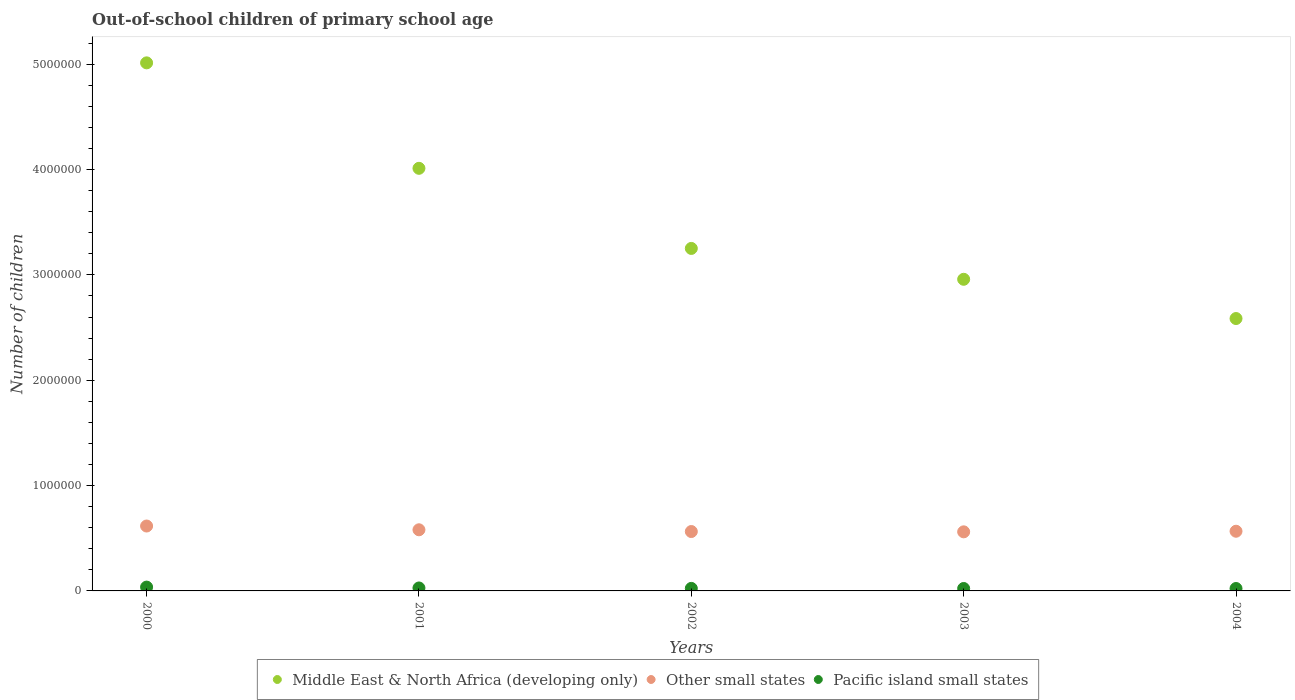How many different coloured dotlines are there?
Your answer should be very brief. 3. Is the number of dotlines equal to the number of legend labels?
Keep it short and to the point. Yes. What is the number of out-of-school children in Other small states in 2001?
Keep it short and to the point. 5.80e+05. Across all years, what is the maximum number of out-of-school children in Middle East & North Africa (developing only)?
Ensure brevity in your answer.  5.01e+06. Across all years, what is the minimum number of out-of-school children in Pacific island small states?
Make the answer very short. 2.30e+04. What is the total number of out-of-school children in Other small states in the graph?
Offer a terse response. 2.89e+06. What is the difference between the number of out-of-school children in Middle East & North Africa (developing only) in 2001 and that in 2004?
Your answer should be very brief. 1.43e+06. What is the difference between the number of out-of-school children in Other small states in 2004 and the number of out-of-school children in Pacific island small states in 2000?
Ensure brevity in your answer.  5.30e+05. What is the average number of out-of-school children in Other small states per year?
Keep it short and to the point. 5.78e+05. In the year 2004, what is the difference between the number of out-of-school children in Middle East & North Africa (developing only) and number of out-of-school children in Other small states?
Your answer should be very brief. 2.02e+06. What is the ratio of the number of out-of-school children in Other small states in 2002 to that in 2003?
Your answer should be very brief. 1.01. Is the number of out-of-school children in Pacific island small states in 2000 less than that in 2001?
Your answer should be compact. No. What is the difference between the highest and the second highest number of out-of-school children in Other small states?
Ensure brevity in your answer.  3.57e+04. What is the difference between the highest and the lowest number of out-of-school children in Pacific island small states?
Make the answer very short. 1.33e+04. Is it the case that in every year, the sum of the number of out-of-school children in Middle East & North Africa (developing only) and number of out-of-school children in Other small states  is greater than the number of out-of-school children in Pacific island small states?
Your answer should be compact. Yes. Is the number of out-of-school children in Pacific island small states strictly greater than the number of out-of-school children in Middle East & North Africa (developing only) over the years?
Provide a short and direct response. No. Is the number of out-of-school children in Middle East & North Africa (developing only) strictly less than the number of out-of-school children in Other small states over the years?
Your response must be concise. No. Are the values on the major ticks of Y-axis written in scientific E-notation?
Ensure brevity in your answer.  No. Does the graph contain grids?
Your response must be concise. No. How many legend labels are there?
Make the answer very short. 3. What is the title of the graph?
Make the answer very short. Out-of-school children of primary school age. What is the label or title of the Y-axis?
Keep it short and to the point. Number of children. What is the Number of children of Middle East & North Africa (developing only) in 2000?
Ensure brevity in your answer.  5.01e+06. What is the Number of children in Other small states in 2000?
Provide a short and direct response. 6.16e+05. What is the Number of children in Pacific island small states in 2000?
Your answer should be very brief. 3.63e+04. What is the Number of children of Middle East & North Africa (developing only) in 2001?
Your answer should be compact. 4.01e+06. What is the Number of children of Other small states in 2001?
Provide a short and direct response. 5.80e+05. What is the Number of children of Pacific island small states in 2001?
Keep it short and to the point. 2.80e+04. What is the Number of children in Middle East & North Africa (developing only) in 2002?
Your response must be concise. 3.25e+06. What is the Number of children of Other small states in 2002?
Your response must be concise. 5.64e+05. What is the Number of children of Pacific island small states in 2002?
Make the answer very short. 2.40e+04. What is the Number of children of Middle East & North Africa (developing only) in 2003?
Your response must be concise. 2.96e+06. What is the Number of children in Other small states in 2003?
Your response must be concise. 5.61e+05. What is the Number of children of Pacific island small states in 2003?
Keep it short and to the point. 2.30e+04. What is the Number of children in Middle East & North Africa (developing only) in 2004?
Keep it short and to the point. 2.59e+06. What is the Number of children in Other small states in 2004?
Provide a succinct answer. 5.67e+05. What is the Number of children of Pacific island small states in 2004?
Keep it short and to the point. 2.30e+04. Across all years, what is the maximum Number of children in Middle East & North Africa (developing only)?
Provide a succinct answer. 5.01e+06. Across all years, what is the maximum Number of children in Other small states?
Ensure brevity in your answer.  6.16e+05. Across all years, what is the maximum Number of children in Pacific island small states?
Provide a succinct answer. 3.63e+04. Across all years, what is the minimum Number of children of Middle East & North Africa (developing only)?
Keep it short and to the point. 2.59e+06. Across all years, what is the minimum Number of children of Other small states?
Offer a very short reply. 5.61e+05. Across all years, what is the minimum Number of children of Pacific island small states?
Offer a terse response. 2.30e+04. What is the total Number of children in Middle East & North Africa (developing only) in the graph?
Keep it short and to the point. 1.78e+07. What is the total Number of children in Other small states in the graph?
Offer a very short reply. 2.89e+06. What is the total Number of children of Pacific island small states in the graph?
Offer a terse response. 1.34e+05. What is the difference between the Number of children in Middle East & North Africa (developing only) in 2000 and that in 2001?
Offer a terse response. 1.00e+06. What is the difference between the Number of children in Other small states in 2000 and that in 2001?
Provide a short and direct response. 3.57e+04. What is the difference between the Number of children of Pacific island small states in 2000 and that in 2001?
Your answer should be compact. 8231. What is the difference between the Number of children in Middle East & North Africa (developing only) in 2000 and that in 2002?
Your answer should be very brief. 1.76e+06. What is the difference between the Number of children in Other small states in 2000 and that in 2002?
Your answer should be very brief. 5.24e+04. What is the difference between the Number of children of Pacific island small states in 2000 and that in 2002?
Your answer should be compact. 1.23e+04. What is the difference between the Number of children in Middle East & North Africa (developing only) in 2000 and that in 2003?
Your answer should be compact. 2.05e+06. What is the difference between the Number of children of Other small states in 2000 and that in 2003?
Provide a succinct answer. 5.52e+04. What is the difference between the Number of children of Pacific island small states in 2000 and that in 2003?
Keep it short and to the point. 1.33e+04. What is the difference between the Number of children in Middle East & North Africa (developing only) in 2000 and that in 2004?
Ensure brevity in your answer.  2.43e+06. What is the difference between the Number of children in Other small states in 2000 and that in 2004?
Your answer should be very brief. 4.96e+04. What is the difference between the Number of children in Pacific island small states in 2000 and that in 2004?
Your answer should be very brief. 1.33e+04. What is the difference between the Number of children in Middle East & North Africa (developing only) in 2001 and that in 2002?
Offer a very short reply. 7.60e+05. What is the difference between the Number of children in Other small states in 2001 and that in 2002?
Your response must be concise. 1.66e+04. What is the difference between the Number of children in Pacific island small states in 2001 and that in 2002?
Give a very brief answer. 4058. What is the difference between the Number of children in Middle East & North Africa (developing only) in 2001 and that in 2003?
Your answer should be compact. 1.05e+06. What is the difference between the Number of children of Other small states in 2001 and that in 2003?
Offer a very short reply. 1.95e+04. What is the difference between the Number of children in Pacific island small states in 2001 and that in 2003?
Your answer should be compact. 5020. What is the difference between the Number of children of Middle East & North Africa (developing only) in 2001 and that in 2004?
Ensure brevity in your answer.  1.43e+06. What is the difference between the Number of children of Other small states in 2001 and that in 2004?
Give a very brief answer. 1.38e+04. What is the difference between the Number of children of Pacific island small states in 2001 and that in 2004?
Your answer should be compact. 5055. What is the difference between the Number of children in Middle East & North Africa (developing only) in 2002 and that in 2003?
Give a very brief answer. 2.93e+05. What is the difference between the Number of children in Other small states in 2002 and that in 2003?
Ensure brevity in your answer.  2824. What is the difference between the Number of children of Pacific island small states in 2002 and that in 2003?
Give a very brief answer. 962. What is the difference between the Number of children in Middle East & North Africa (developing only) in 2002 and that in 2004?
Your response must be concise. 6.65e+05. What is the difference between the Number of children of Other small states in 2002 and that in 2004?
Make the answer very short. -2803. What is the difference between the Number of children of Pacific island small states in 2002 and that in 2004?
Your answer should be compact. 997. What is the difference between the Number of children of Middle East & North Africa (developing only) in 2003 and that in 2004?
Offer a terse response. 3.73e+05. What is the difference between the Number of children of Other small states in 2003 and that in 2004?
Your response must be concise. -5627. What is the difference between the Number of children of Pacific island small states in 2003 and that in 2004?
Your answer should be compact. 35. What is the difference between the Number of children in Middle East & North Africa (developing only) in 2000 and the Number of children in Other small states in 2001?
Provide a short and direct response. 4.43e+06. What is the difference between the Number of children in Middle East & North Africa (developing only) in 2000 and the Number of children in Pacific island small states in 2001?
Ensure brevity in your answer.  4.98e+06. What is the difference between the Number of children of Other small states in 2000 and the Number of children of Pacific island small states in 2001?
Your answer should be very brief. 5.88e+05. What is the difference between the Number of children in Middle East & North Africa (developing only) in 2000 and the Number of children in Other small states in 2002?
Keep it short and to the point. 4.45e+06. What is the difference between the Number of children in Middle East & North Africa (developing only) in 2000 and the Number of children in Pacific island small states in 2002?
Keep it short and to the point. 4.99e+06. What is the difference between the Number of children in Other small states in 2000 and the Number of children in Pacific island small states in 2002?
Give a very brief answer. 5.92e+05. What is the difference between the Number of children of Middle East & North Africa (developing only) in 2000 and the Number of children of Other small states in 2003?
Give a very brief answer. 4.45e+06. What is the difference between the Number of children of Middle East & North Africa (developing only) in 2000 and the Number of children of Pacific island small states in 2003?
Keep it short and to the point. 4.99e+06. What is the difference between the Number of children in Other small states in 2000 and the Number of children in Pacific island small states in 2003?
Ensure brevity in your answer.  5.93e+05. What is the difference between the Number of children in Middle East & North Africa (developing only) in 2000 and the Number of children in Other small states in 2004?
Provide a succinct answer. 4.45e+06. What is the difference between the Number of children of Middle East & North Africa (developing only) in 2000 and the Number of children of Pacific island small states in 2004?
Offer a terse response. 4.99e+06. What is the difference between the Number of children in Other small states in 2000 and the Number of children in Pacific island small states in 2004?
Your response must be concise. 5.93e+05. What is the difference between the Number of children of Middle East & North Africa (developing only) in 2001 and the Number of children of Other small states in 2002?
Your response must be concise. 3.45e+06. What is the difference between the Number of children of Middle East & North Africa (developing only) in 2001 and the Number of children of Pacific island small states in 2002?
Your answer should be very brief. 3.99e+06. What is the difference between the Number of children in Other small states in 2001 and the Number of children in Pacific island small states in 2002?
Give a very brief answer. 5.56e+05. What is the difference between the Number of children of Middle East & North Africa (developing only) in 2001 and the Number of children of Other small states in 2003?
Offer a very short reply. 3.45e+06. What is the difference between the Number of children of Middle East & North Africa (developing only) in 2001 and the Number of children of Pacific island small states in 2003?
Provide a short and direct response. 3.99e+06. What is the difference between the Number of children in Other small states in 2001 and the Number of children in Pacific island small states in 2003?
Keep it short and to the point. 5.57e+05. What is the difference between the Number of children of Middle East & North Africa (developing only) in 2001 and the Number of children of Other small states in 2004?
Provide a succinct answer. 3.45e+06. What is the difference between the Number of children of Middle East & North Africa (developing only) in 2001 and the Number of children of Pacific island small states in 2004?
Your response must be concise. 3.99e+06. What is the difference between the Number of children in Other small states in 2001 and the Number of children in Pacific island small states in 2004?
Offer a terse response. 5.57e+05. What is the difference between the Number of children in Middle East & North Africa (developing only) in 2002 and the Number of children in Other small states in 2003?
Your answer should be compact. 2.69e+06. What is the difference between the Number of children of Middle East & North Africa (developing only) in 2002 and the Number of children of Pacific island small states in 2003?
Your answer should be compact. 3.23e+06. What is the difference between the Number of children of Other small states in 2002 and the Number of children of Pacific island small states in 2003?
Your response must be concise. 5.41e+05. What is the difference between the Number of children in Middle East & North Africa (developing only) in 2002 and the Number of children in Other small states in 2004?
Ensure brevity in your answer.  2.68e+06. What is the difference between the Number of children of Middle East & North Africa (developing only) in 2002 and the Number of children of Pacific island small states in 2004?
Provide a succinct answer. 3.23e+06. What is the difference between the Number of children in Other small states in 2002 and the Number of children in Pacific island small states in 2004?
Ensure brevity in your answer.  5.41e+05. What is the difference between the Number of children in Middle East & North Africa (developing only) in 2003 and the Number of children in Other small states in 2004?
Make the answer very short. 2.39e+06. What is the difference between the Number of children in Middle East & North Africa (developing only) in 2003 and the Number of children in Pacific island small states in 2004?
Provide a succinct answer. 2.94e+06. What is the difference between the Number of children in Other small states in 2003 and the Number of children in Pacific island small states in 2004?
Keep it short and to the point. 5.38e+05. What is the average Number of children of Middle East & North Africa (developing only) per year?
Provide a short and direct response. 3.56e+06. What is the average Number of children in Other small states per year?
Give a very brief answer. 5.78e+05. What is the average Number of children of Pacific island small states per year?
Your response must be concise. 2.69e+04. In the year 2000, what is the difference between the Number of children of Middle East & North Africa (developing only) and Number of children of Other small states?
Ensure brevity in your answer.  4.40e+06. In the year 2000, what is the difference between the Number of children of Middle East & North Africa (developing only) and Number of children of Pacific island small states?
Your answer should be compact. 4.98e+06. In the year 2000, what is the difference between the Number of children of Other small states and Number of children of Pacific island small states?
Offer a terse response. 5.80e+05. In the year 2001, what is the difference between the Number of children in Middle East & North Africa (developing only) and Number of children in Other small states?
Your answer should be compact. 3.43e+06. In the year 2001, what is the difference between the Number of children of Middle East & North Africa (developing only) and Number of children of Pacific island small states?
Your response must be concise. 3.98e+06. In the year 2001, what is the difference between the Number of children in Other small states and Number of children in Pacific island small states?
Your answer should be compact. 5.52e+05. In the year 2002, what is the difference between the Number of children of Middle East & North Africa (developing only) and Number of children of Other small states?
Give a very brief answer. 2.69e+06. In the year 2002, what is the difference between the Number of children of Middle East & North Africa (developing only) and Number of children of Pacific island small states?
Offer a terse response. 3.23e+06. In the year 2002, what is the difference between the Number of children of Other small states and Number of children of Pacific island small states?
Make the answer very short. 5.40e+05. In the year 2003, what is the difference between the Number of children in Middle East & North Africa (developing only) and Number of children in Other small states?
Provide a succinct answer. 2.40e+06. In the year 2003, what is the difference between the Number of children of Middle East & North Africa (developing only) and Number of children of Pacific island small states?
Your answer should be compact. 2.94e+06. In the year 2003, what is the difference between the Number of children in Other small states and Number of children in Pacific island small states?
Your answer should be very brief. 5.38e+05. In the year 2004, what is the difference between the Number of children of Middle East & North Africa (developing only) and Number of children of Other small states?
Make the answer very short. 2.02e+06. In the year 2004, what is the difference between the Number of children of Middle East & North Africa (developing only) and Number of children of Pacific island small states?
Give a very brief answer. 2.56e+06. In the year 2004, what is the difference between the Number of children of Other small states and Number of children of Pacific island small states?
Your response must be concise. 5.44e+05. What is the ratio of the Number of children of Middle East & North Africa (developing only) in 2000 to that in 2001?
Offer a very short reply. 1.25. What is the ratio of the Number of children in Other small states in 2000 to that in 2001?
Give a very brief answer. 1.06. What is the ratio of the Number of children of Pacific island small states in 2000 to that in 2001?
Make the answer very short. 1.29. What is the ratio of the Number of children in Middle East & North Africa (developing only) in 2000 to that in 2002?
Ensure brevity in your answer.  1.54. What is the ratio of the Number of children of Other small states in 2000 to that in 2002?
Make the answer very short. 1.09. What is the ratio of the Number of children of Pacific island small states in 2000 to that in 2002?
Ensure brevity in your answer.  1.51. What is the ratio of the Number of children in Middle East & North Africa (developing only) in 2000 to that in 2003?
Provide a succinct answer. 1.69. What is the ratio of the Number of children of Other small states in 2000 to that in 2003?
Offer a terse response. 1.1. What is the ratio of the Number of children in Pacific island small states in 2000 to that in 2003?
Offer a very short reply. 1.58. What is the ratio of the Number of children in Middle East & North Africa (developing only) in 2000 to that in 2004?
Keep it short and to the point. 1.94. What is the ratio of the Number of children of Other small states in 2000 to that in 2004?
Your answer should be compact. 1.09. What is the ratio of the Number of children in Pacific island small states in 2000 to that in 2004?
Your answer should be compact. 1.58. What is the ratio of the Number of children of Middle East & North Africa (developing only) in 2001 to that in 2002?
Your answer should be compact. 1.23. What is the ratio of the Number of children of Other small states in 2001 to that in 2002?
Offer a terse response. 1.03. What is the ratio of the Number of children in Pacific island small states in 2001 to that in 2002?
Your answer should be compact. 1.17. What is the ratio of the Number of children of Middle East & North Africa (developing only) in 2001 to that in 2003?
Offer a very short reply. 1.36. What is the ratio of the Number of children of Other small states in 2001 to that in 2003?
Offer a very short reply. 1.03. What is the ratio of the Number of children of Pacific island small states in 2001 to that in 2003?
Provide a succinct answer. 1.22. What is the ratio of the Number of children in Middle East & North Africa (developing only) in 2001 to that in 2004?
Your answer should be compact. 1.55. What is the ratio of the Number of children in Other small states in 2001 to that in 2004?
Your answer should be very brief. 1.02. What is the ratio of the Number of children in Pacific island small states in 2001 to that in 2004?
Make the answer very short. 1.22. What is the ratio of the Number of children of Middle East & North Africa (developing only) in 2002 to that in 2003?
Make the answer very short. 1.1. What is the ratio of the Number of children of Other small states in 2002 to that in 2003?
Make the answer very short. 1. What is the ratio of the Number of children of Pacific island small states in 2002 to that in 2003?
Keep it short and to the point. 1.04. What is the ratio of the Number of children in Middle East & North Africa (developing only) in 2002 to that in 2004?
Your answer should be very brief. 1.26. What is the ratio of the Number of children in Pacific island small states in 2002 to that in 2004?
Provide a succinct answer. 1.04. What is the ratio of the Number of children in Middle East & North Africa (developing only) in 2003 to that in 2004?
Your answer should be very brief. 1.14. What is the ratio of the Number of children of Other small states in 2003 to that in 2004?
Offer a terse response. 0.99. What is the ratio of the Number of children in Pacific island small states in 2003 to that in 2004?
Provide a short and direct response. 1. What is the difference between the highest and the second highest Number of children of Middle East & North Africa (developing only)?
Offer a very short reply. 1.00e+06. What is the difference between the highest and the second highest Number of children in Other small states?
Provide a short and direct response. 3.57e+04. What is the difference between the highest and the second highest Number of children of Pacific island small states?
Make the answer very short. 8231. What is the difference between the highest and the lowest Number of children in Middle East & North Africa (developing only)?
Provide a short and direct response. 2.43e+06. What is the difference between the highest and the lowest Number of children of Other small states?
Give a very brief answer. 5.52e+04. What is the difference between the highest and the lowest Number of children of Pacific island small states?
Keep it short and to the point. 1.33e+04. 